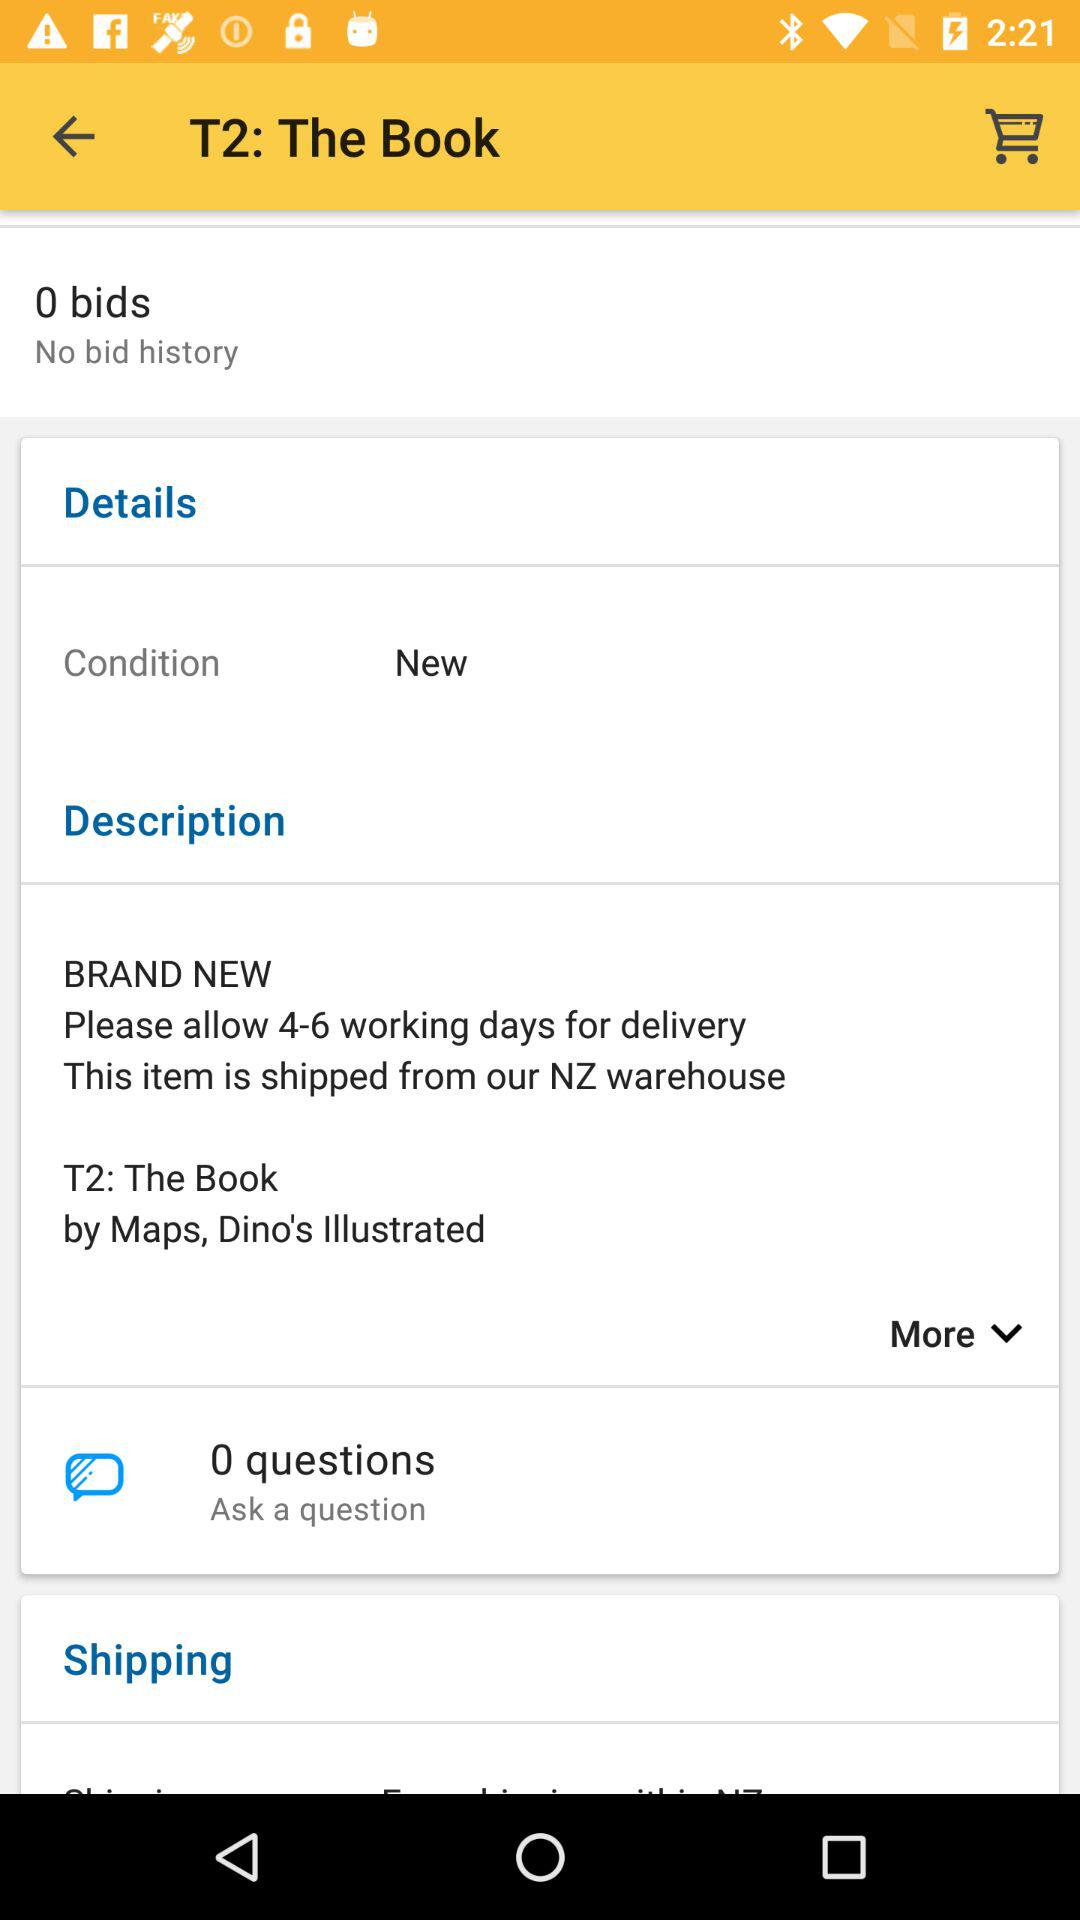How many days does it take to deliver this item? It takes 4-6 working days to deliver this item. 